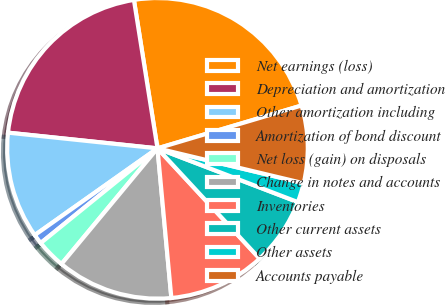Convert chart. <chart><loc_0><loc_0><loc_500><loc_500><pie_chart><fcel>Net earnings (loss)<fcel>Depreciation and amortization<fcel>Other amortization including<fcel>Amortization of bond discount<fcel>Net loss (gain) on disposals<fcel>Change in notes and accounts<fcel>Inventories<fcel>Other current assets<fcel>Other assets<fcel>Accounts payable<nl><fcel>22.91%<fcel>20.83%<fcel>11.46%<fcel>1.05%<fcel>3.13%<fcel>12.5%<fcel>10.42%<fcel>7.29%<fcel>2.09%<fcel>8.33%<nl></chart> 